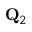Convert formula to latex. <formula><loc_0><loc_0><loc_500><loc_500>{ Q } _ { 2 }</formula> 